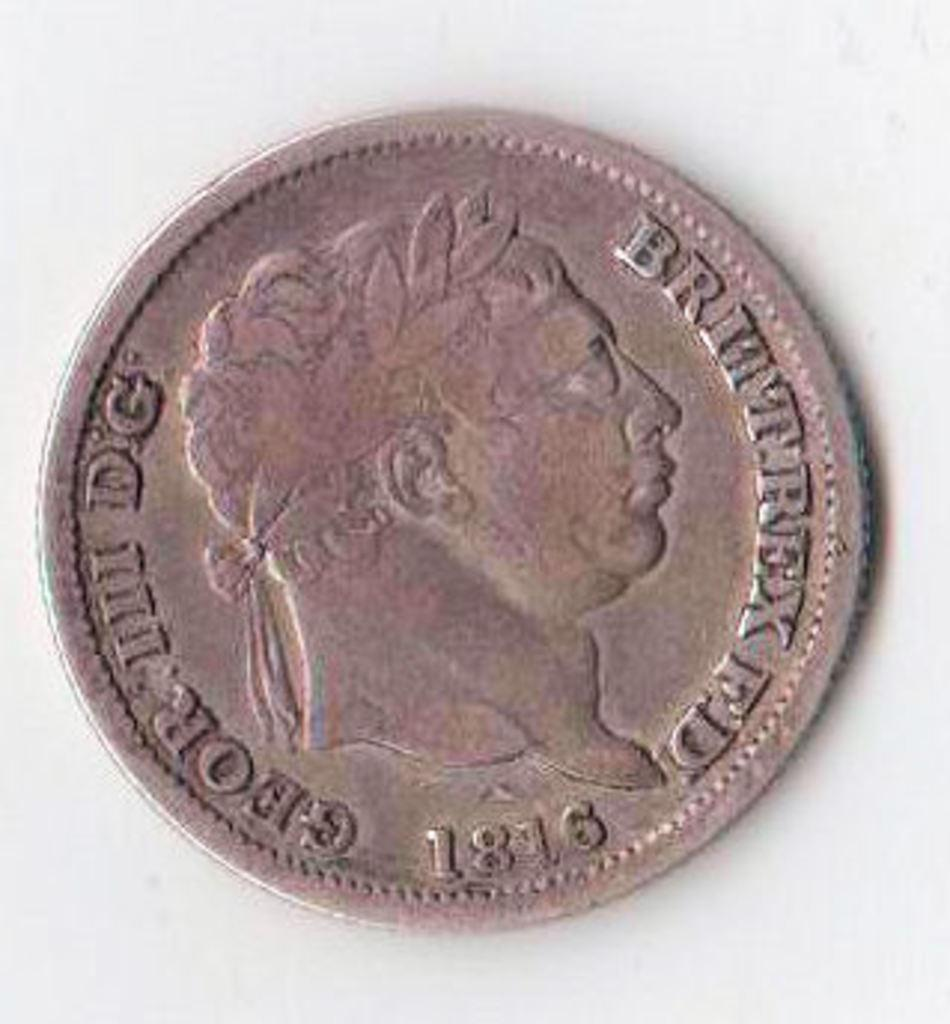<image>
Describe the image concisely. Copper coins showing a face and the year 1816. 